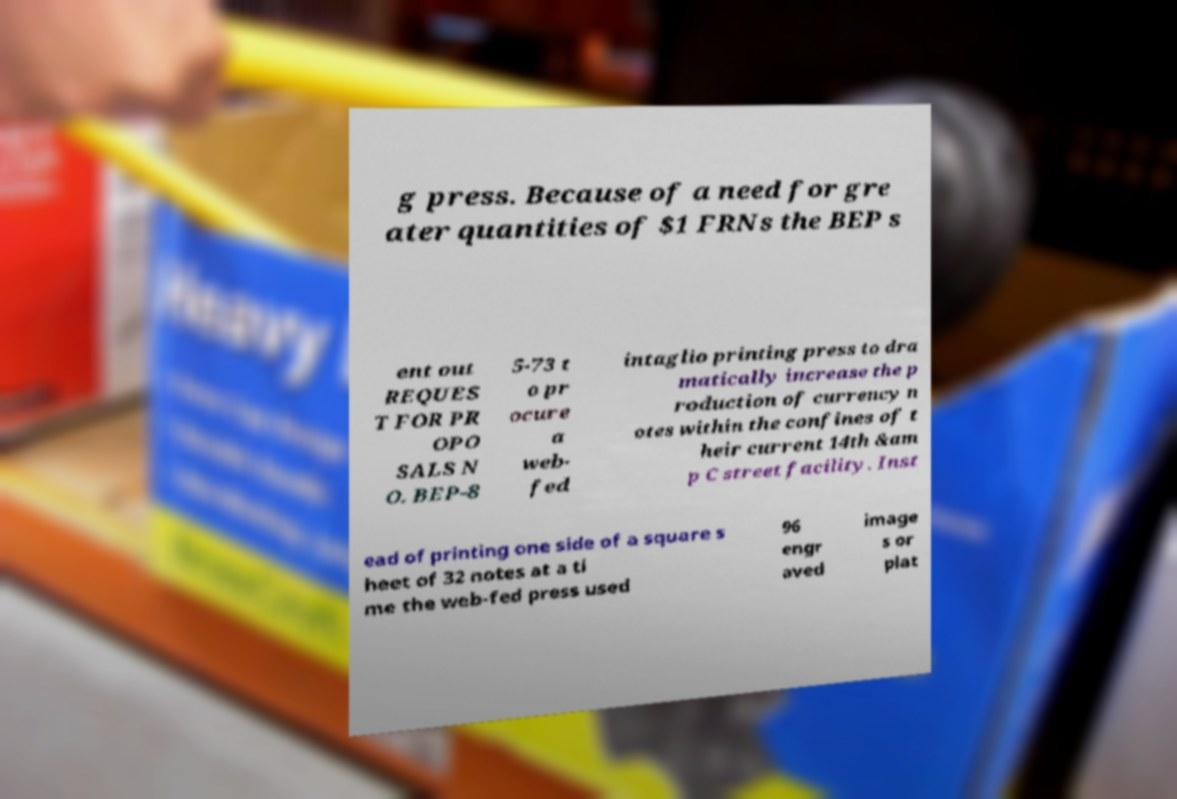Could you extract and type out the text from this image? g press. Because of a need for gre ater quantities of $1 FRNs the BEP s ent out REQUES T FOR PR OPO SALS N O. BEP-8 5-73 t o pr ocure a web- fed intaglio printing press to dra matically increase the p roduction of currency n otes within the confines of t heir current 14th &am p C street facility. Inst ead of printing one side of a square s heet of 32 notes at a ti me the web-fed press used 96 engr aved image s or plat 